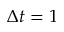Convert formula to latex. <formula><loc_0><loc_0><loc_500><loc_500>\Delta t = 1</formula> 